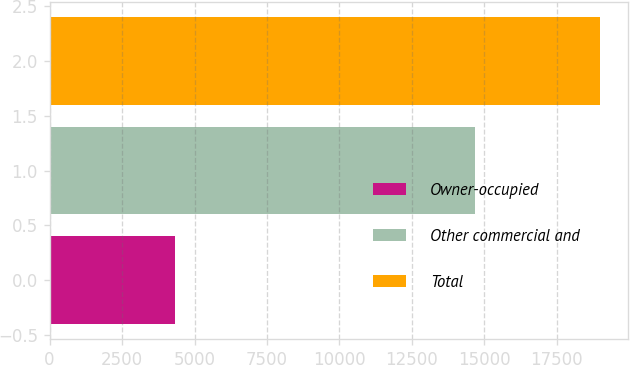<chart> <loc_0><loc_0><loc_500><loc_500><bar_chart><fcel>Owner-occupied<fcel>Other commercial and<fcel>Total<nl><fcel>4320<fcel>14676<fcel>18996<nl></chart> 